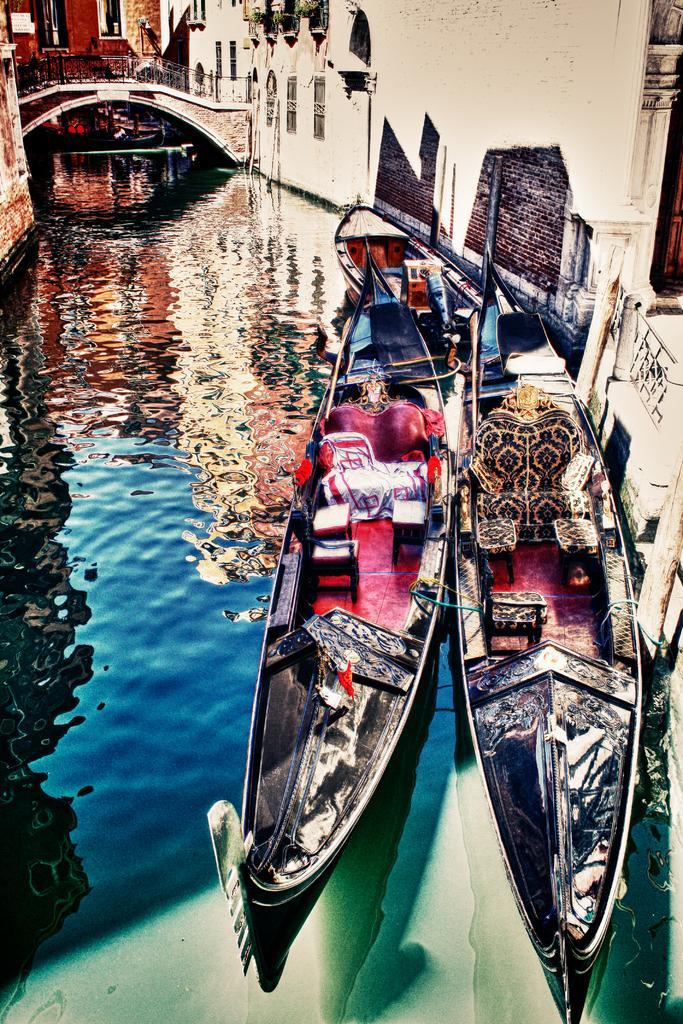Describe this image in one or two sentences. the image is looking like an edited image. In the foreground there are boats and a canal. At the top there are buildings and a bridge. On the right it is well. 